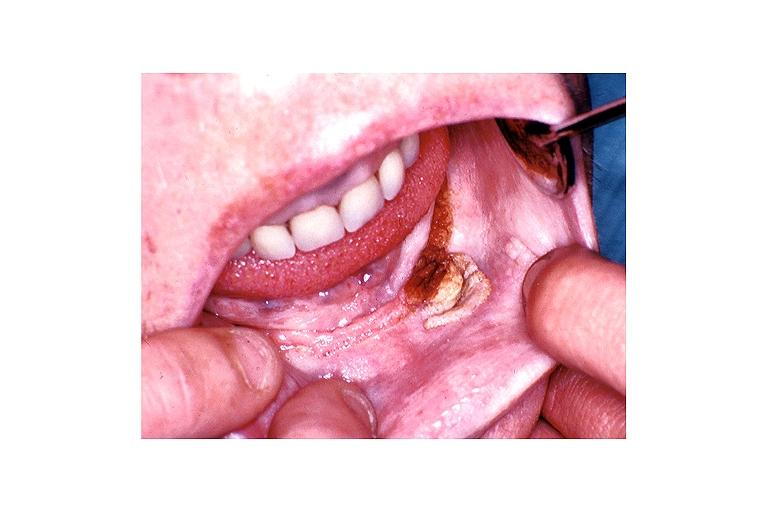what is present?
Answer the question using a single word or phrase. Oral 